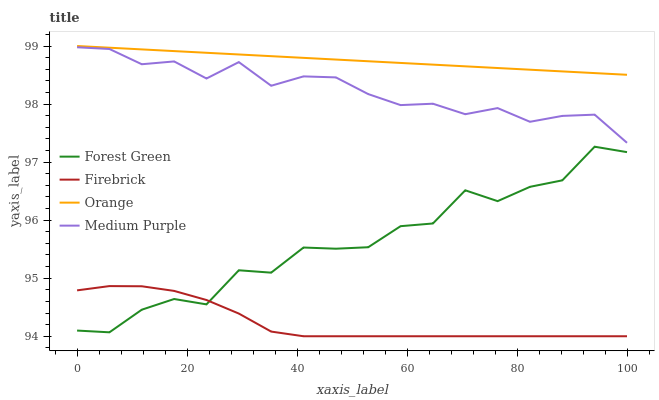Does Firebrick have the minimum area under the curve?
Answer yes or no. Yes. Does Orange have the maximum area under the curve?
Answer yes or no. Yes. Does Medium Purple have the minimum area under the curve?
Answer yes or no. No. Does Medium Purple have the maximum area under the curve?
Answer yes or no. No. Is Orange the smoothest?
Answer yes or no. Yes. Is Forest Green the roughest?
Answer yes or no. Yes. Is Medium Purple the smoothest?
Answer yes or no. No. Is Medium Purple the roughest?
Answer yes or no. No. Does Firebrick have the lowest value?
Answer yes or no. Yes. Does Medium Purple have the lowest value?
Answer yes or no. No. Does Orange have the highest value?
Answer yes or no. Yes. Does Medium Purple have the highest value?
Answer yes or no. No. Is Forest Green less than Medium Purple?
Answer yes or no. Yes. Is Orange greater than Forest Green?
Answer yes or no. Yes. Does Firebrick intersect Forest Green?
Answer yes or no. Yes. Is Firebrick less than Forest Green?
Answer yes or no. No. Is Firebrick greater than Forest Green?
Answer yes or no. No. Does Forest Green intersect Medium Purple?
Answer yes or no. No. 